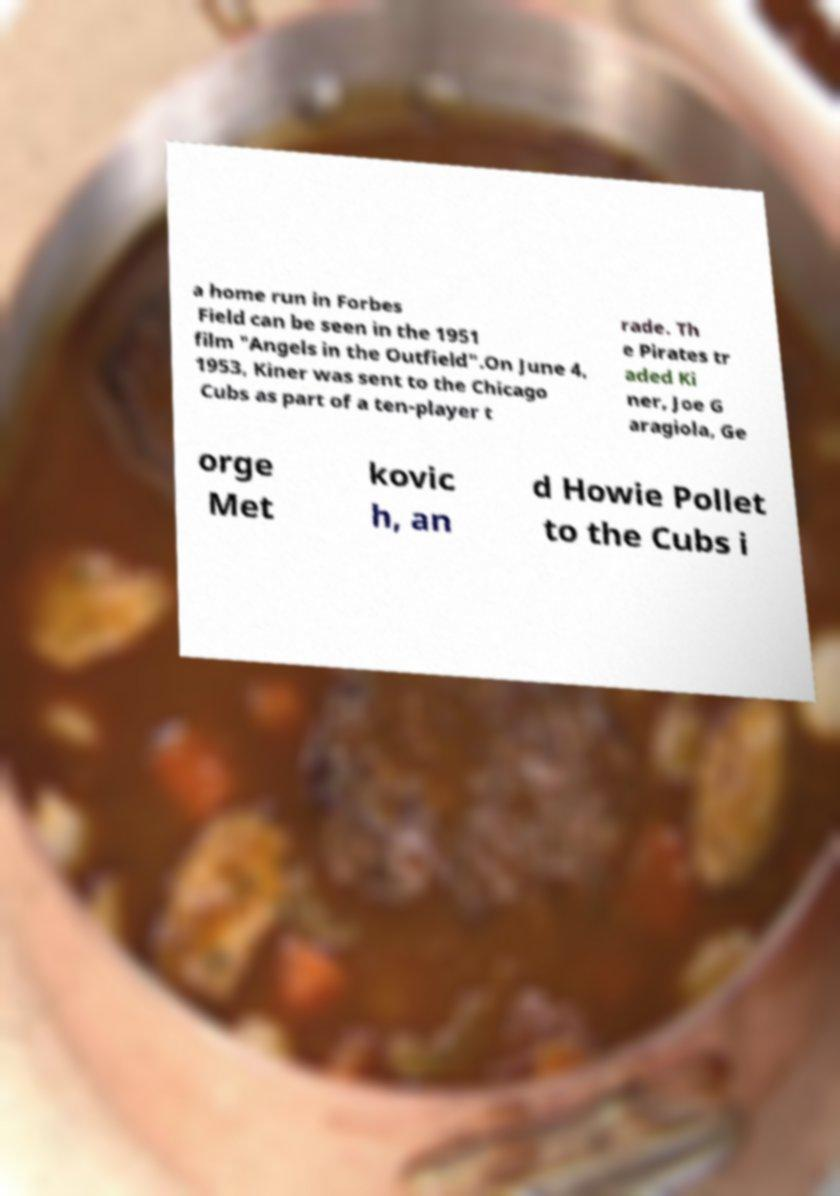Can you accurately transcribe the text from the provided image for me? a home run in Forbes Field can be seen in the 1951 film "Angels in the Outfield".On June 4, 1953, Kiner was sent to the Chicago Cubs as part of a ten-player t rade. Th e Pirates tr aded Ki ner, Joe G aragiola, Ge orge Met kovic h, an d Howie Pollet to the Cubs i 